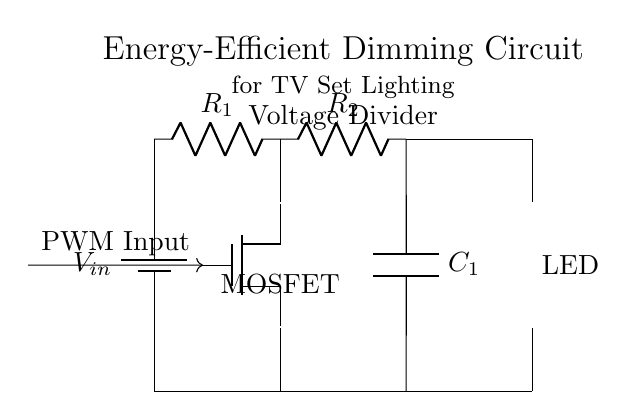What is the total number of components in this circuit? The circuit diagram displays a total of four components: one battery, one MOSFET, two resistors, and one capacitor, totaling four distinct components.
Answer: four What type of MOSFET is used in the circuit? The diagram indicates the presence of an n-channel MOSFET, which is typically used in dimming circuits for its properties of switching and amplification.
Answer: n-channel What is the role of R1 and R2 in the circuit? R1 and R2 form a voltage divider that controls the gate voltage of the MOSFET. This configuration helps to set the brightness level of the LED based on the PWM input.
Answer: voltage divider What is connected to the gate of the MOSFET? The gate of the MOSFET is connected to the PWM input, which regulates its operation through pulse-width modulation to adjust the LED brightness.
Answer: PWM input How does the capacitor C1 influence the circuit operation? The capacitor C1 filters the output, smoothing the rapid changes in current that occur due to the PWM signal applied to the MOSFET, resulting in steadier LED illumination.
Answer: smooths current What would happen if R1 was removed from the circuit? Removing R1 would disrupt the voltage divider effect of R1 and R2, likely preventing the proper gate voltage from reaching the MOSFET, which could cause the LED to not dim effectively.
Answer: disrupted dimming What is the function of the LED in this circuit? The LED serves as the light source that provides adjustable lighting based on the dimming control from the MOSFET, allowing variations in brightness for the television set.
Answer: light source 